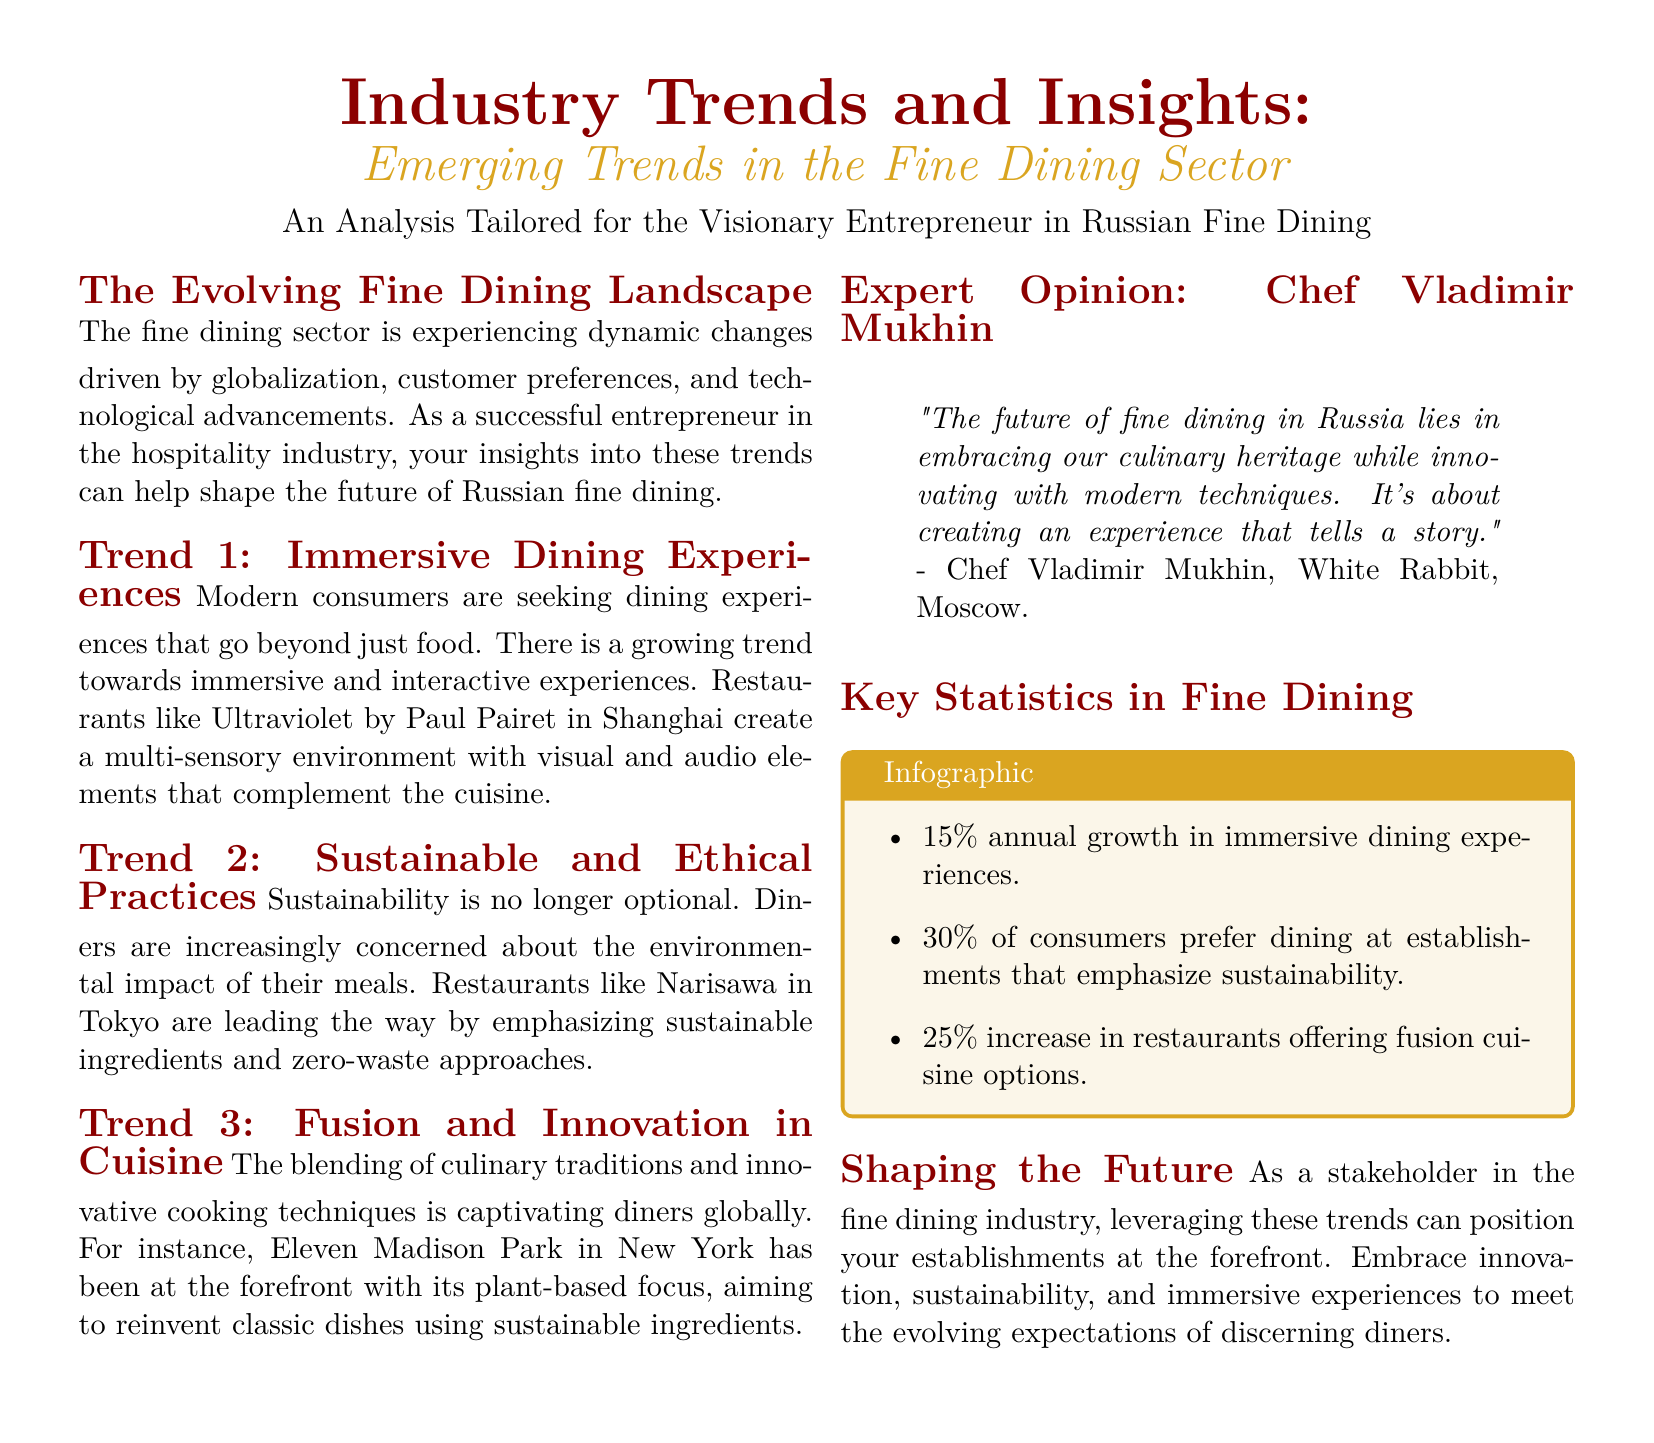What is the title of the document? The title is presented at the top of the document as the main focus, stating the main subject matter.
Answer: Industry Trends and Insights: Emerging Trends in the Fine Dining Sector Who provided the expert opinion featured in the document? The expert opinion is attributed to a notable figure in the fine dining industry, highlighting their insights.
Answer: Chef Vladimir Mukhin What percentage of consumers prefer dining at establishments that emphasize sustainability? The document includes statistical information regarding consumer preferences for sustainability in dining.
Answer: 30% Which restaurant is known for its immersive dining experience mentioned in the document? The document references a specific establishment that exemplifies the immersive dining trend.
Answer: Ultraviolet by Paul Pairet What is the annual growth percentage of immersive dining experiences? The document provides numerical insights on the growth trends within the fine dining sector.
Answer: 15% What culinary focus is Eleven Madison Park known for? The document indicates a specific innovative trend in cuisine adopted by this restaurant.
Answer: Plant-based focus 